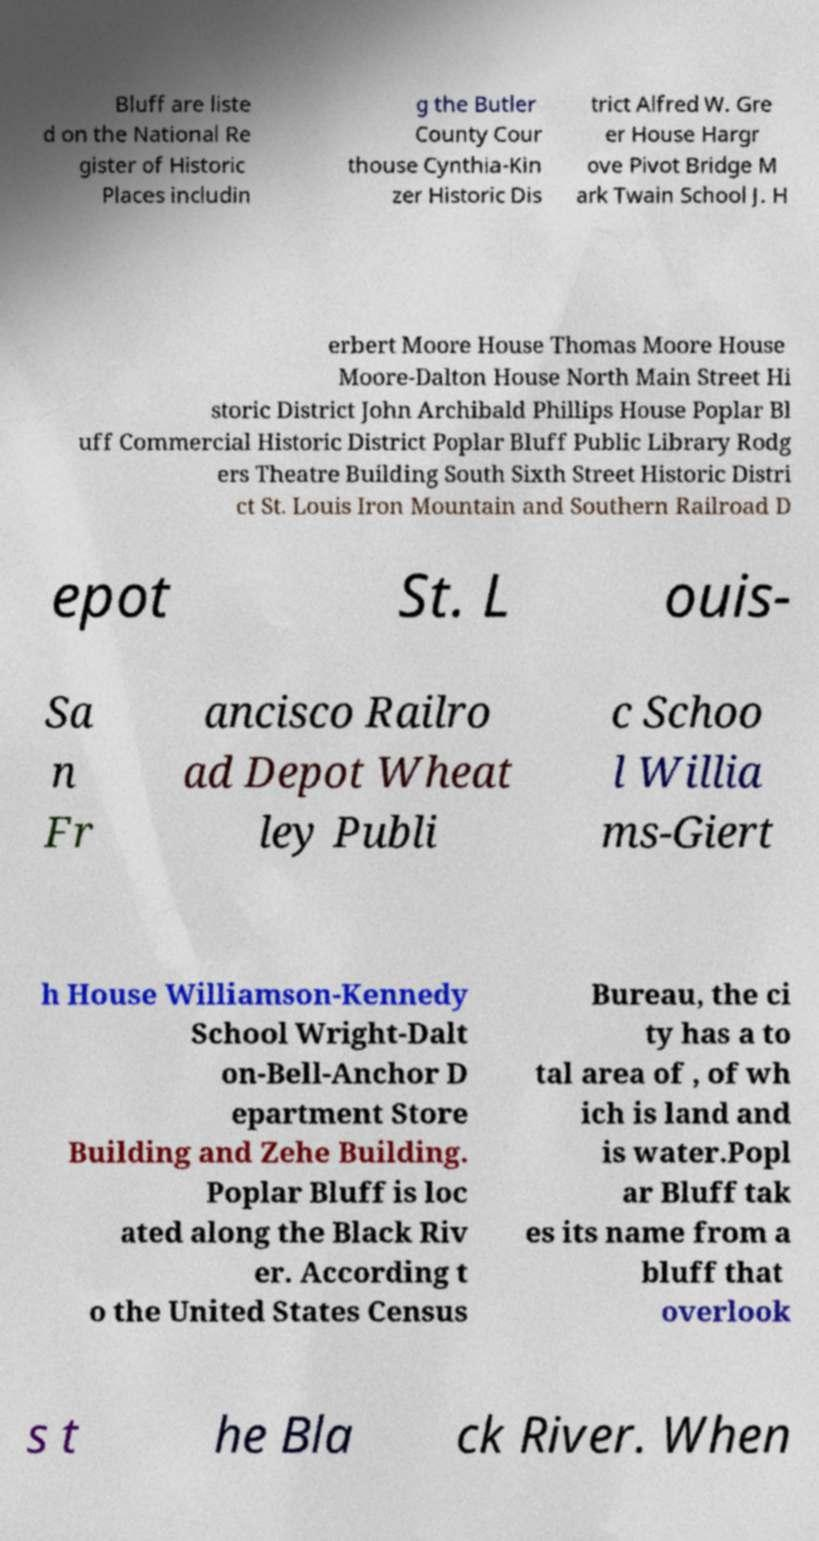Can you accurately transcribe the text from the provided image for me? Bluff are liste d on the National Re gister of Historic Places includin g the Butler County Cour thouse Cynthia-Kin zer Historic Dis trict Alfred W. Gre er House Hargr ove Pivot Bridge M ark Twain School J. H erbert Moore House Thomas Moore House Moore-Dalton House North Main Street Hi storic District John Archibald Phillips House Poplar Bl uff Commercial Historic District Poplar Bluff Public Library Rodg ers Theatre Building South Sixth Street Historic Distri ct St. Louis Iron Mountain and Southern Railroad D epot St. L ouis- Sa n Fr ancisco Railro ad Depot Wheat ley Publi c Schoo l Willia ms-Giert h House Williamson-Kennedy School Wright-Dalt on-Bell-Anchor D epartment Store Building and Zehe Building. Poplar Bluff is loc ated along the Black Riv er. According t o the United States Census Bureau, the ci ty has a to tal area of , of wh ich is land and is water.Popl ar Bluff tak es its name from a bluff that overlook s t he Bla ck River. When 